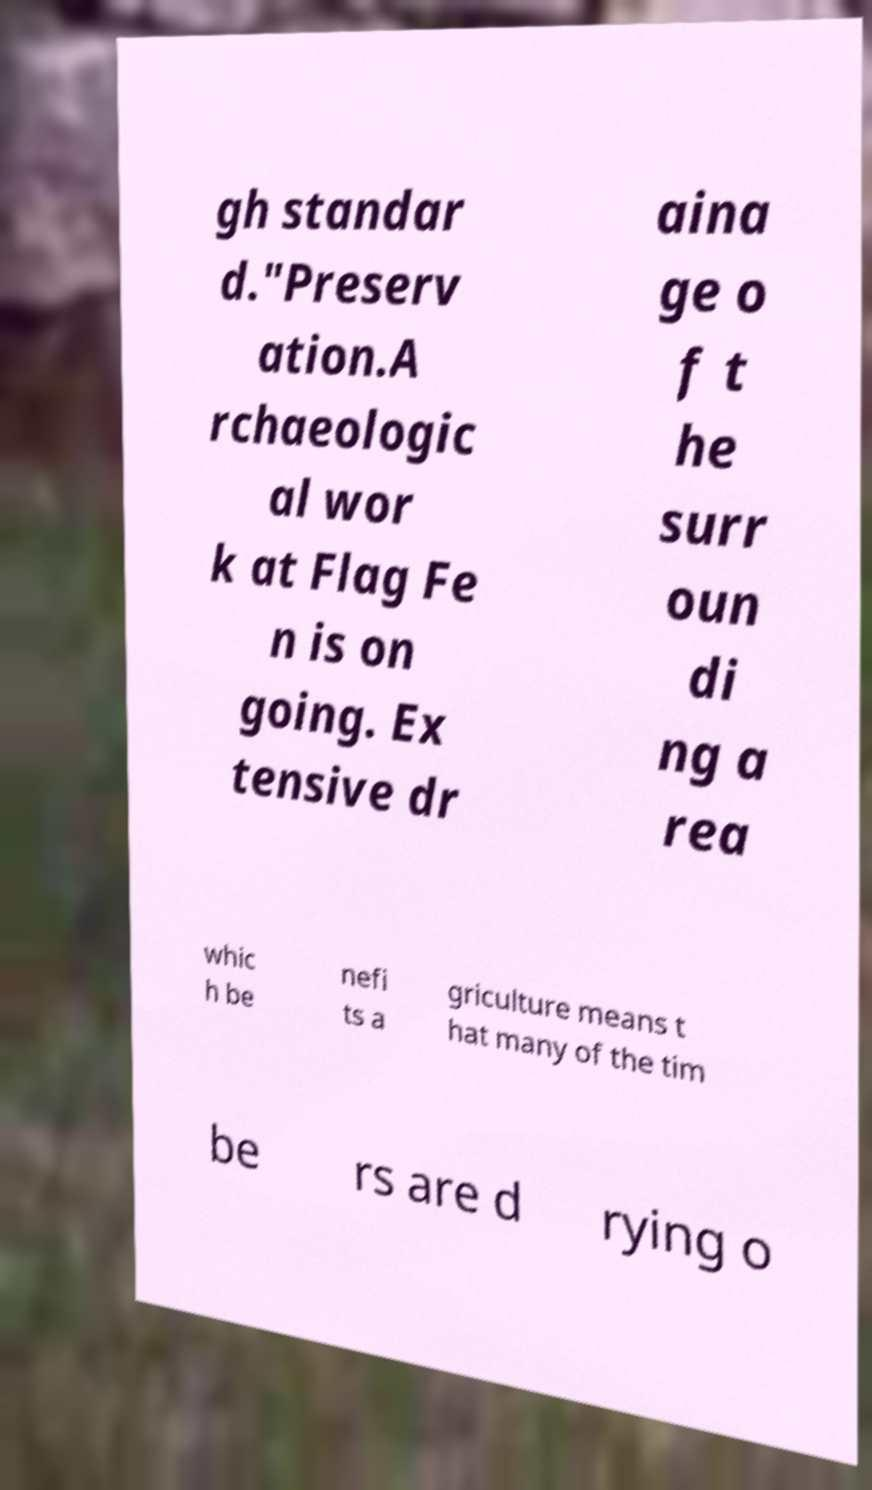Please identify and transcribe the text found in this image. gh standar d."Preserv ation.A rchaeologic al wor k at Flag Fe n is on going. Ex tensive dr aina ge o f t he surr oun di ng a rea whic h be nefi ts a griculture means t hat many of the tim be rs are d rying o 